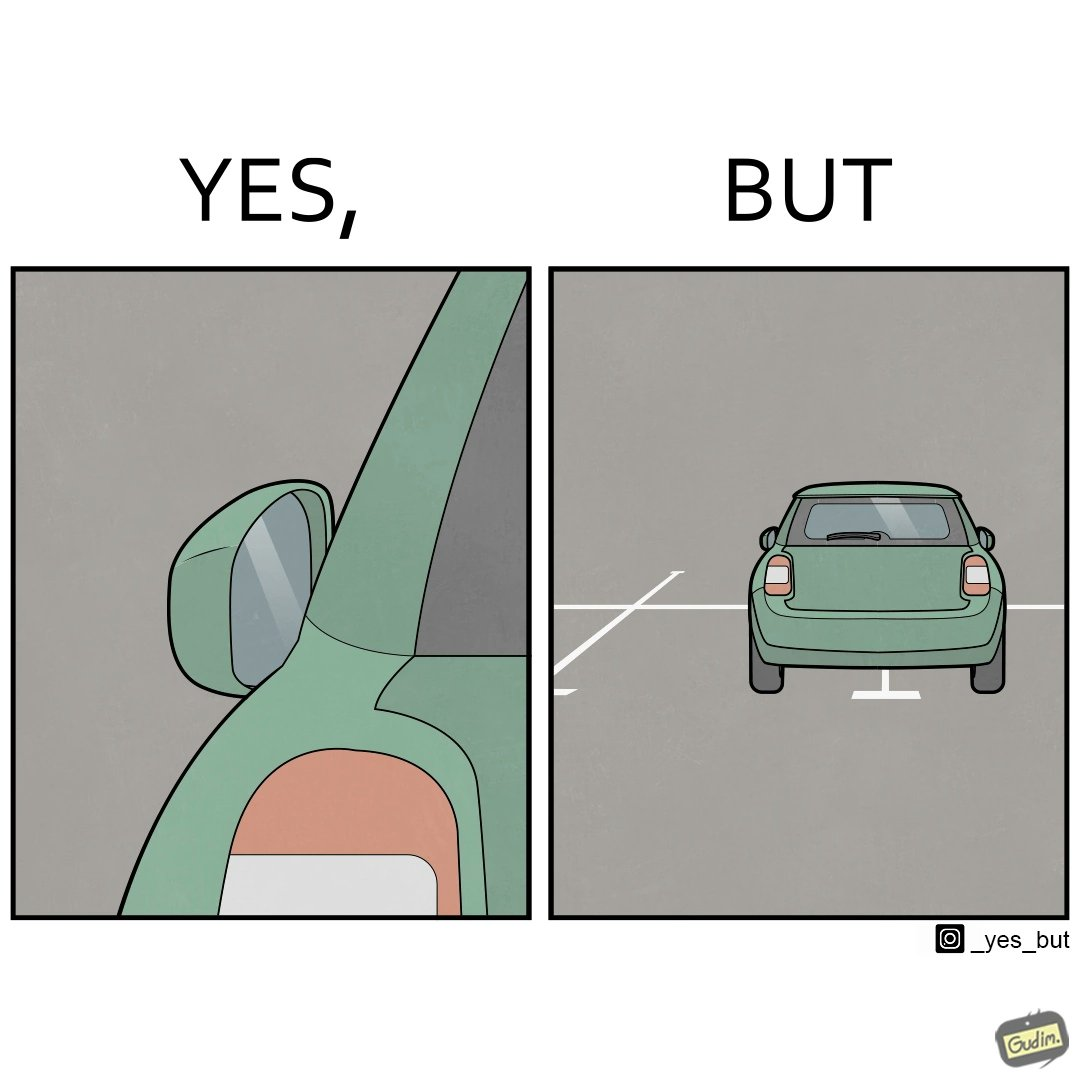Provide a description of this image. The image is funny becuase while folding the side mirrors is good when the car is not being used because it prevents damage but it is supposed to be used while driving and parking the car which has not been done in this case leading the car to be parked impropely. 